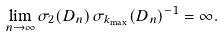Convert formula to latex. <formula><loc_0><loc_0><loc_500><loc_500>\lim _ { n \to \infty } { \sigma _ { 2 } ( D _ { n } ) } \, { \sigma _ { k _ { \max } } ( D _ { n } ) ^ { - 1 } } = \infty .</formula> 